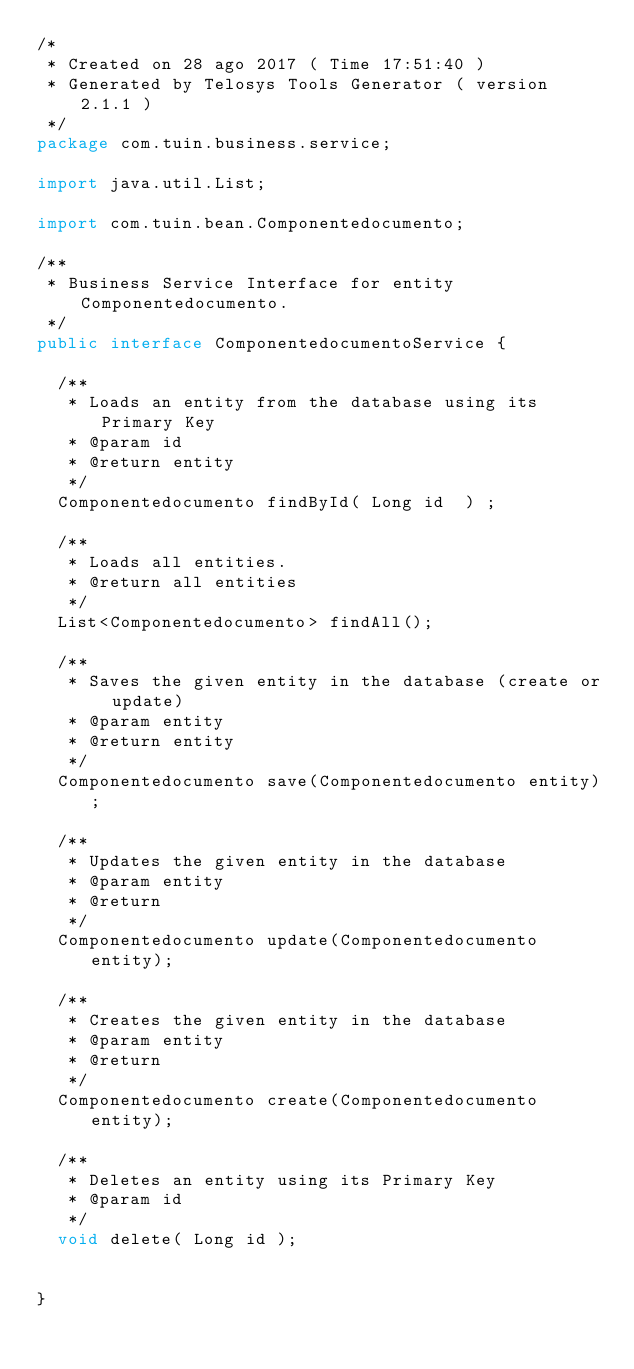<code> <loc_0><loc_0><loc_500><loc_500><_Java_>/*
 * Created on 28 ago 2017 ( Time 17:51:40 )
 * Generated by Telosys Tools Generator ( version 2.1.1 )
 */
package com.tuin.business.service;

import java.util.List;

import com.tuin.bean.Componentedocumento;

/**
 * Business Service Interface for entity Componentedocumento.
 */
public interface ComponentedocumentoService { 

	/**
	 * Loads an entity from the database using its Primary Key
	 * @param id
	 * @return entity
	 */
	Componentedocumento findById( Long id  ) ;

	/**
	 * Loads all entities.
	 * @return all entities
	 */
	List<Componentedocumento> findAll();

	/**
	 * Saves the given entity in the database (create or update)
	 * @param entity
	 * @return entity
	 */
	Componentedocumento save(Componentedocumento entity);

	/**
	 * Updates the given entity in the database
	 * @param entity
	 * @return
	 */
	Componentedocumento update(Componentedocumento entity);

	/**
	 * Creates the given entity in the database
	 * @param entity
	 * @return
	 */
	Componentedocumento create(Componentedocumento entity);

	/**
	 * Deletes an entity using its Primary Key
	 * @param id
	 */
	void delete( Long id );


}
</code> 